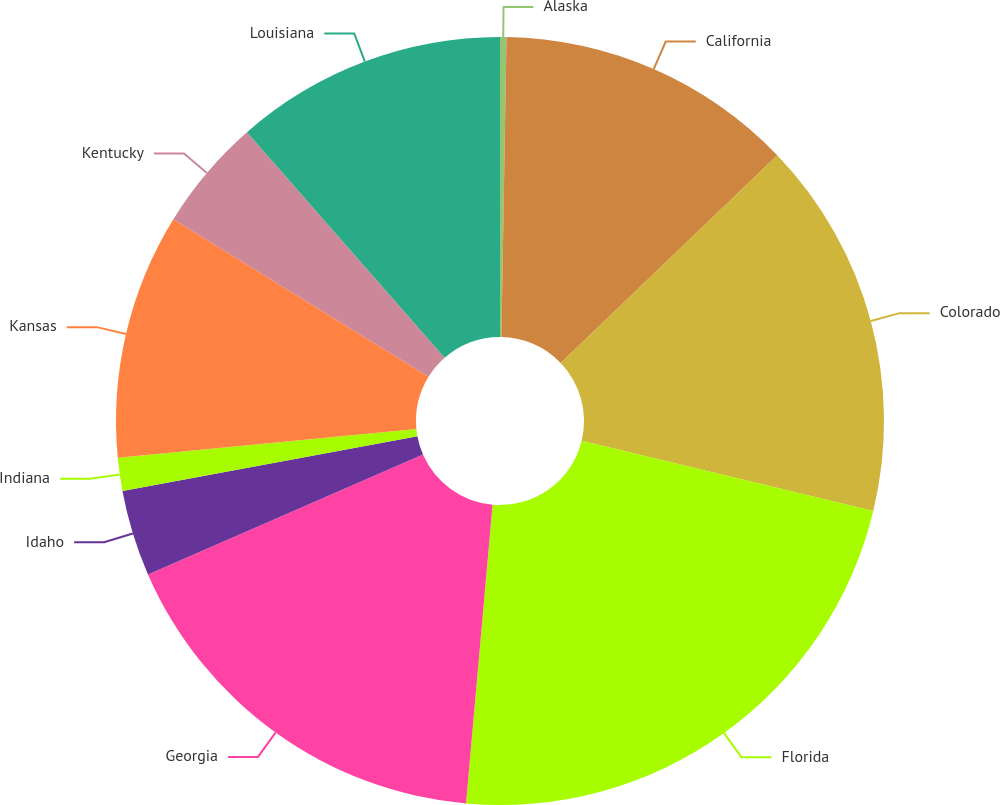<chart> <loc_0><loc_0><loc_500><loc_500><pie_chart><fcel>Alaska<fcel>California<fcel>Colorado<fcel>Florida<fcel>Georgia<fcel>Idaho<fcel>Indiana<fcel>Kansas<fcel>Kentucky<fcel>Louisiana<nl><fcel>0.27%<fcel>12.57%<fcel>15.93%<fcel>22.64%<fcel>17.05%<fcel>3.62%<fcel>1.39%<fcel>10.34%<fcel>4.74%<fcel>11.45%<nl></chart> 